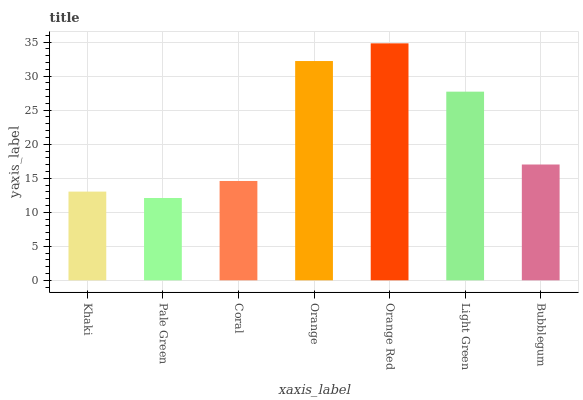Is Pale Green the minimum?
Answer yes or no. Yes. Is Orange Red the maximum?
Answer yes or no. Yes. Is Coral the minimum?
Answer yes or no. No. Is Coral the maximum?
Answer yes or no. No. Is Coral greater than Pale Green?
Answer yes or no. Yes. Is Pale Green less than Coral?
Answer yes or no. Yes. Is Pale Green greater than Coral?
Answer yes or no. No. Is Coral less than Pale Green?
Answer yes or no. No. Is Bubblegum the high median?
Answer yes or no. Yes. Is Bubblegum the low median?
Answer yes or no. Yes. Is Orange the high median?
Answer yes or no. No. Is Light Green the low median?
Answer yes or no. No. 